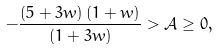Convert formula to latex. <formula><loc_0><loc_0><loc_500><loc_500>- \frac { ( 5 + 3 w ) \left ( 1 + w \right ) } { \left ( 1 + 3 w \right ) } > \mathcal { A } \geq 0 ,</formula> 